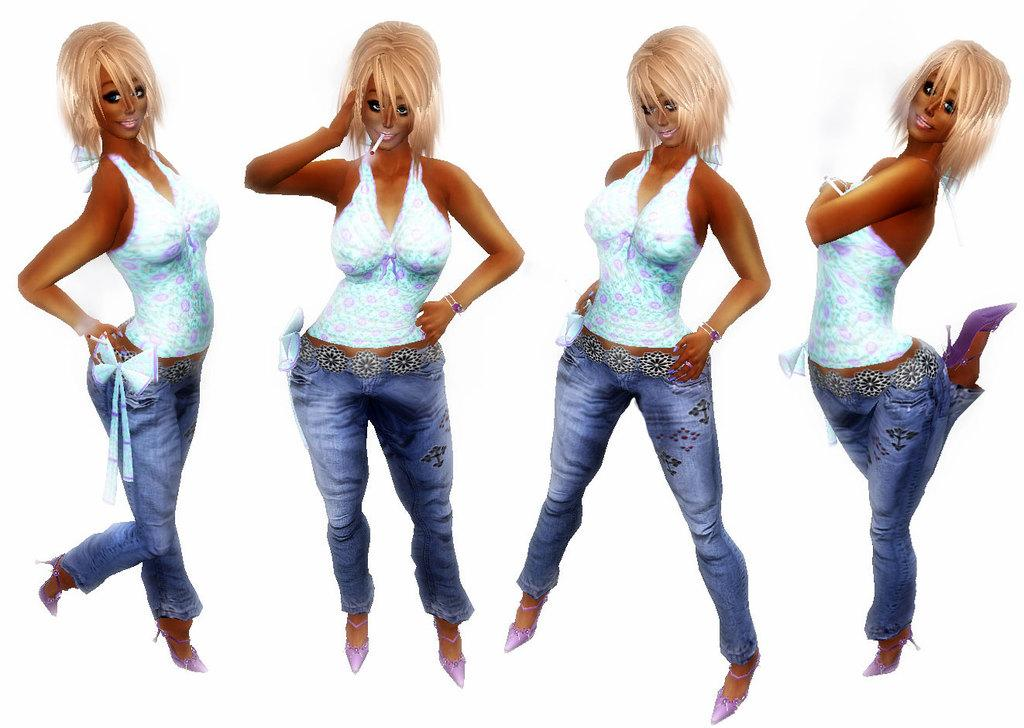Who is the main subject in the image? There is a woman in the image. What is the woman wearing on her upper body? The woman is wearing a blue top. What is the woman wearing on her lower body? The woman is wearing blue jeans. What color is the background of the image? The background of the image is white. Where is the pail located in the image? There is no pail present in the image. What part of the woman's body is missing in the image? The woman's body is complete in the image, and no part is missing. 